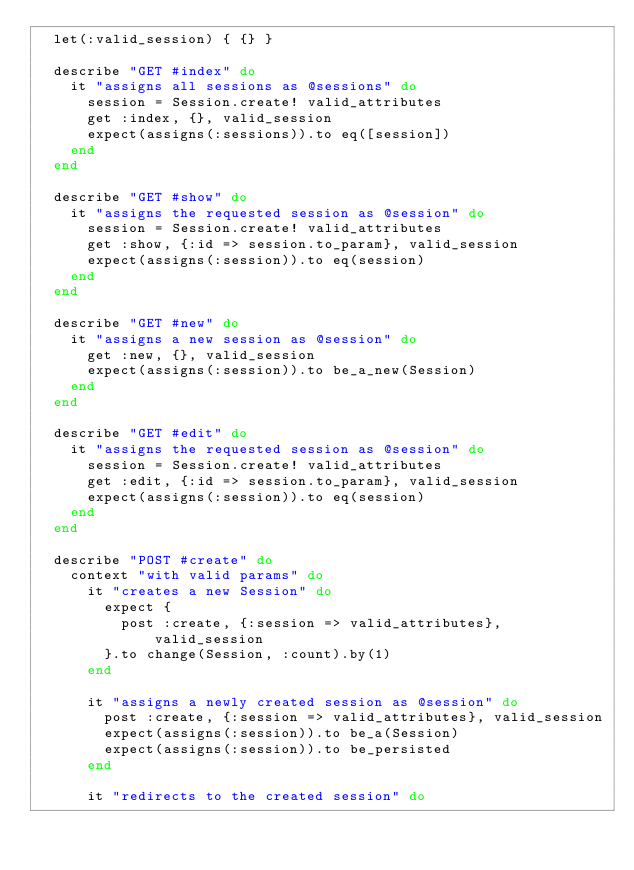Convert code to text. <code><loc_0><loc_0><loc_500><loc_500><_Ruby_>  let(:valid_session) { {} }

  describe "GET #index" do
    it "assigns all sessions as @sessions" do
      session = Session.create! valid_attributes
      get :index, {}, valid_session
      expect(assigns(:sessions)).to eq([session])
    end
  end

  describe "GET #show" do
    it "assigns the requested session as @session" do
      session = Session.create! valid_attributes
      get :show, {:id => session.to_param}, valid_session
      expect(assigns(:session)).to eq(session)
    end
  end

  describe "GET #new" do
    it "assigns a new session as @session" do
      get :new, {}, valid_session
      expect(assigns(:session)).to be_a_new(Session)
    end
  end

  describe "GET #edit" do
    it "assigns the requested session as @session" do
      session = Session.create! valid_attributes
      get :edit, {:id => session.to_param}, valid_session
      expect(assigns(:session)).to eq(session)
    end
  end

  describe "POST #create" do
    context "with valid params" do
      it "creates a new Session" do
        expect {
          post :create, {:session => valid_attributes}, valid_session
        }.to change(Session, :count).by(1)
      end

      it "assigns a newly created session as @session" do
        post :create, {:session => valid_attributes}, valid_session
        expect(assigns(:session)).to be_a(Session)
        expect(assigns(:session)).to be_persisted
      end

      it "redirects to the created session" do</code> 